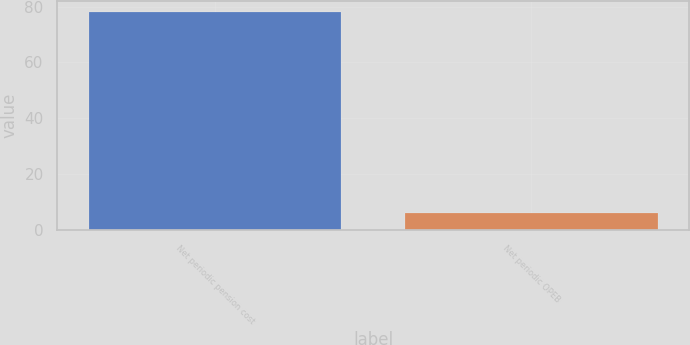Convert chart to OTSL. <chart><loc_0><loc_0><loc_500><loc_500><bar_chart><fcel>Net periodic pension cost<fcel>Net periodic OPEB<nl><fcel>78<fcel>6<nl></chart> 